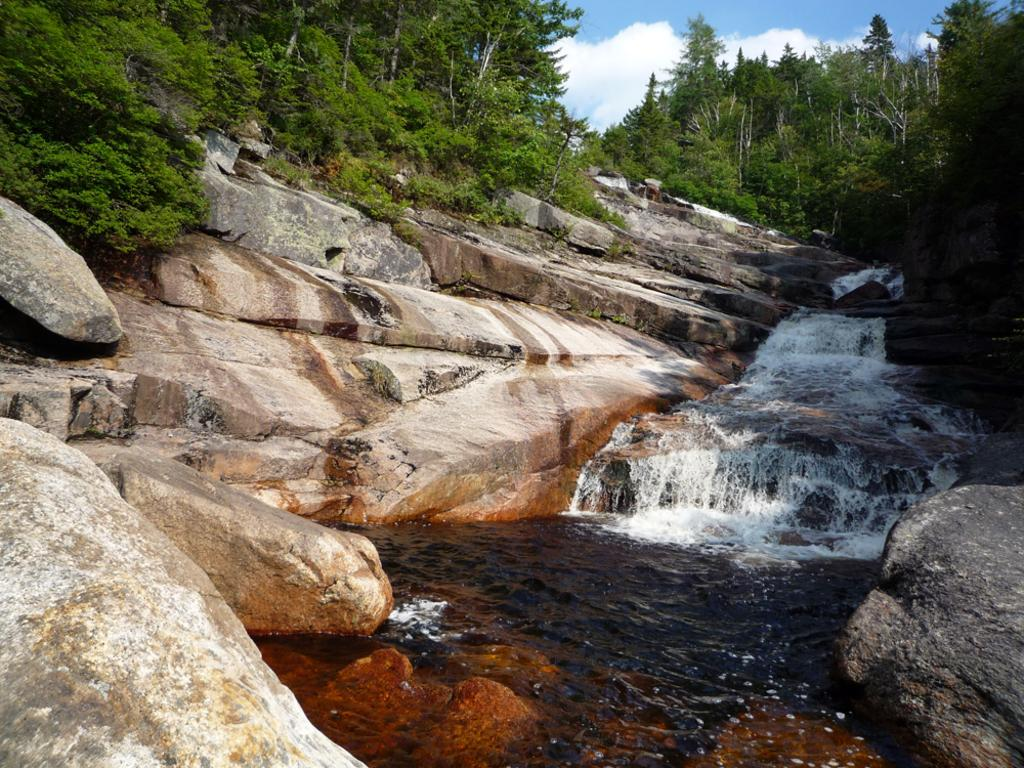What type of natural formations can be seen in the image? There are rocks and waterfalls in the image. What other natural elements are present in the image? There are trees in the image. What is visible in the sky at the top of the image? Clouds are present in the sky at the top of the image. What type of butter is being used to grease the part in the image? There is no butter or part present in the image; it features rocks, waterfalls, trees, and clouds. 